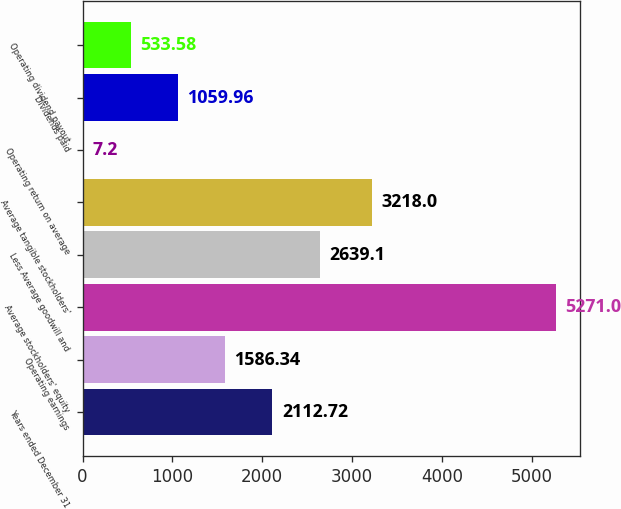Convert chart to OTSL. <chart><loc_0><loc_0><loc_500><loc_500><bar_chart><fcel>Years ended December 31<fcel>Operating earnings<fcel>Average stockholders' equity<fcel>Less Average goodwill and<fcel>Average tangible stockholders'<fcel>Operating return on average<fcel>Dividends paid<fcel>Operating dividend payout<nl><fcel>2112.72<fcel>1586.34<fcel>5271<fcel>2639.1<fcel>3218<fcel>7.2<fcel>1059.96<fcel>533.58<nl></chart> 